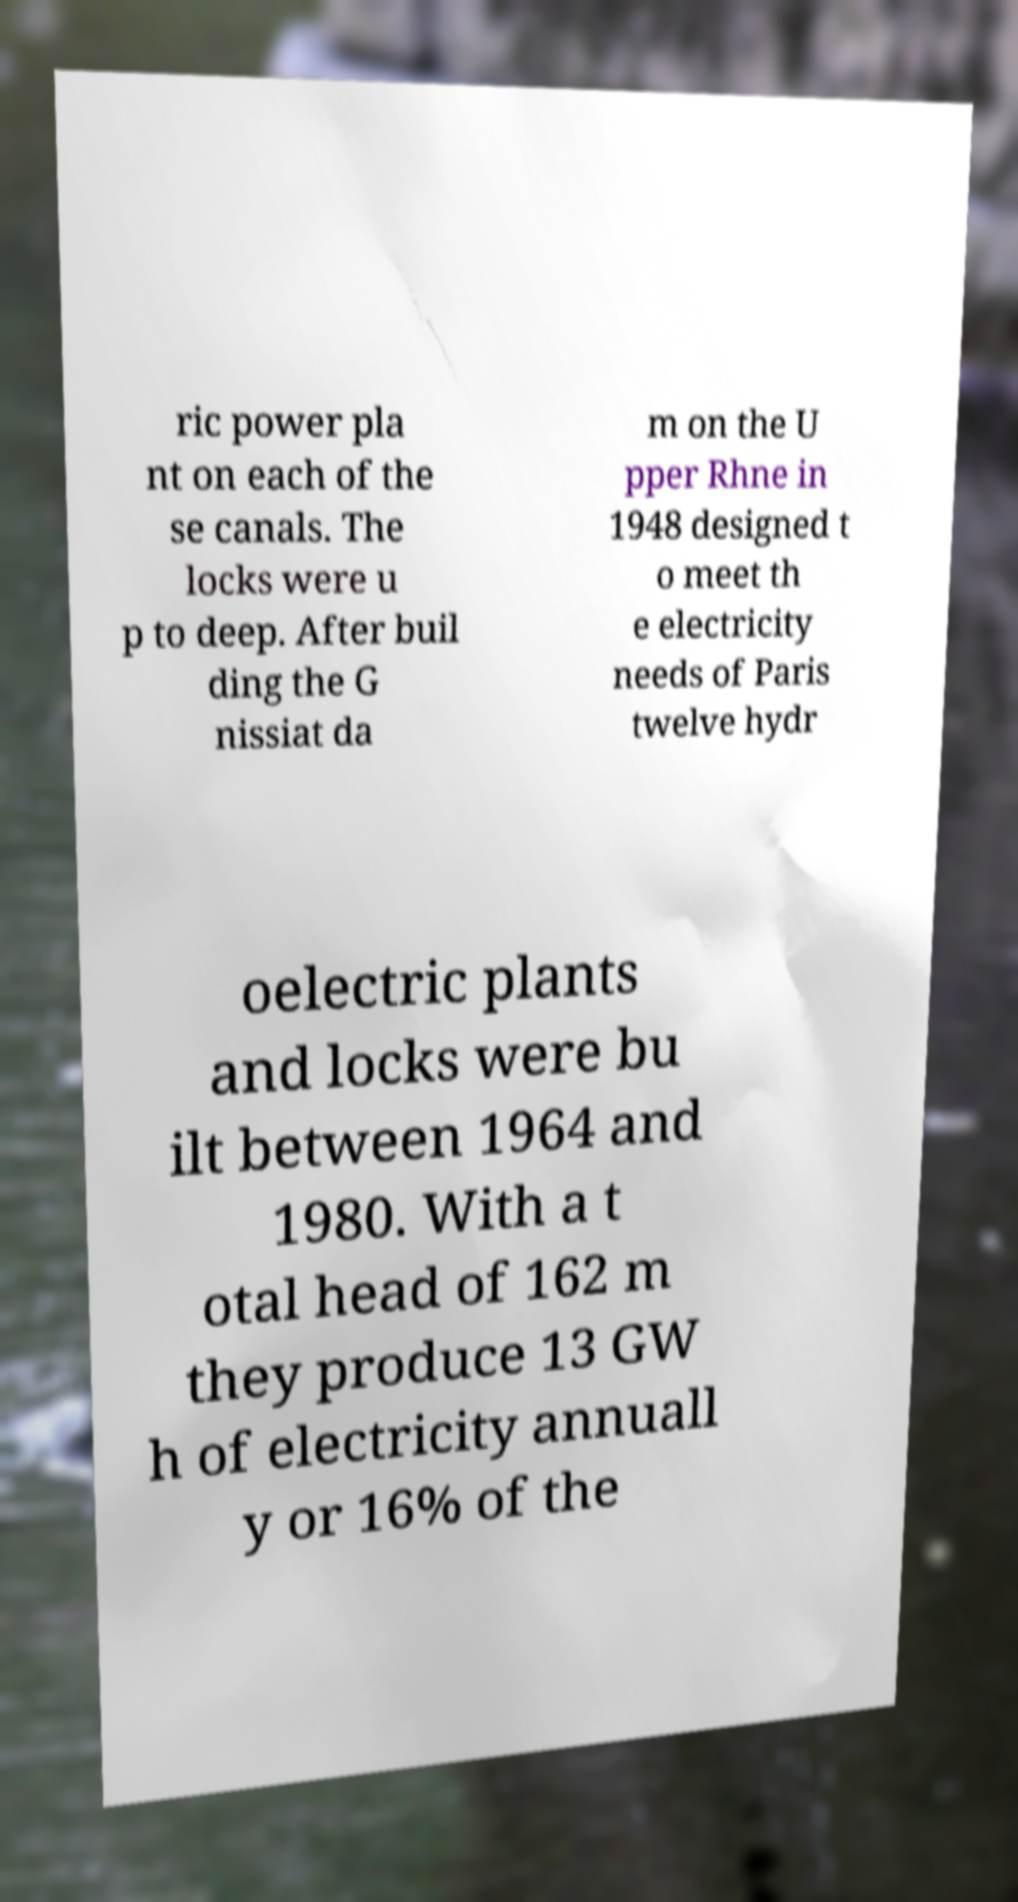Please identify and transcribe the text found in this image. ric power pla nt on each of the se canals. The locks were u p to deep. After buil ding the G nissiat da m on the U pper Rhne in 1948 designed t o meet th e electricity needs of Paris twelve hydr oelectric plants and locks were bu ilt between 1964 and 1980. With a t otal head of 162 m they produce 13 GW h of electricity annuall y or 16% of the 